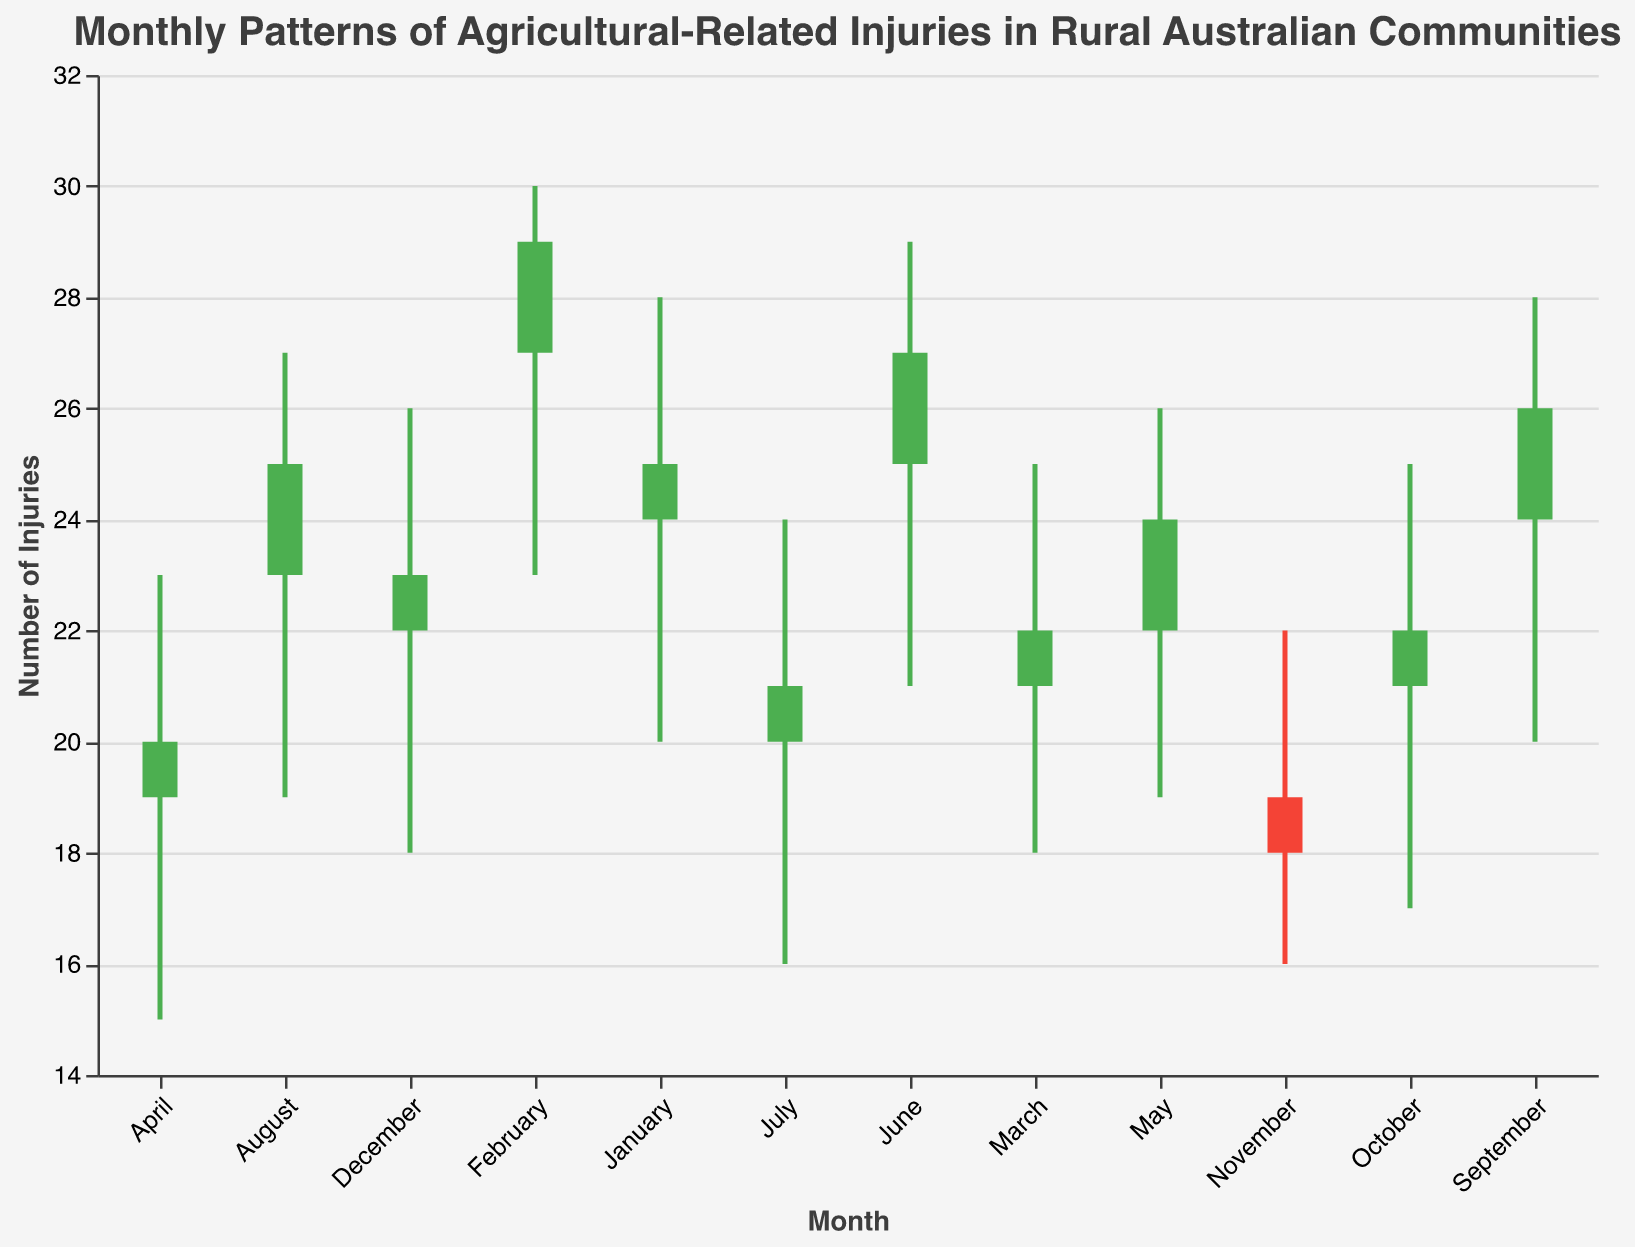What is the highest number of injuries recorded in a single month? The highest number of injuries, according to the "High" values, is 30, recorded in February.
Answer: 30 In which month did the injuries decrease from open to close? The injuries decreased from open to close in March, April, July, October, and November.
Answer: March, April, July, October, November What is the range of injuries recorded in August? The range is calculated by subtracting the low value from the high value: 27 - 19.
Answer: 8 Which month had the lowest low value of injuries? The month with the lowest low value is April, with a low of 15.
Answer: April How many months had an overall increase in the number of injuries from open to close? The months with an increase in injuries from open to close are the ones where the closing value is greater than the opening value: January, February, May, June, August, September, December. Thus, there are 7 months.
Answer: 7 Compare the injury patterns in February and June. Which month had a larger range? February has a range of 30 - 23 = 7, and June has a range of 29 - 21 = 8. June has a larger range.
Answer: June What was the median value of the "low" injuries across all months? The low values are: 15, 16, 16, 18, 18, 19, 19, 20, 20, 21, 23. The median is the middle value in this ordered list, which is 19.
Answer: 19 Which month had the smallest difference between the open and close values? November had the smallest difference between the open and close values, with a difference of 19 - 18 = 1.
Answer: November What is the sum of the highest recorded injuries across all months? Adding up the high values: 28 + 30 + 25 + 23 + 26 + 29 + 24 + 27 + 28 + 25 + 22 + 26 = 313.
Answer: 313 What trend do you observe in the number of injuries from January to December? There are fluctuations, with no consistent trend. The number of injuries increases in some months and decreases in others.
Answer: Fluctuations with no consistent trend 